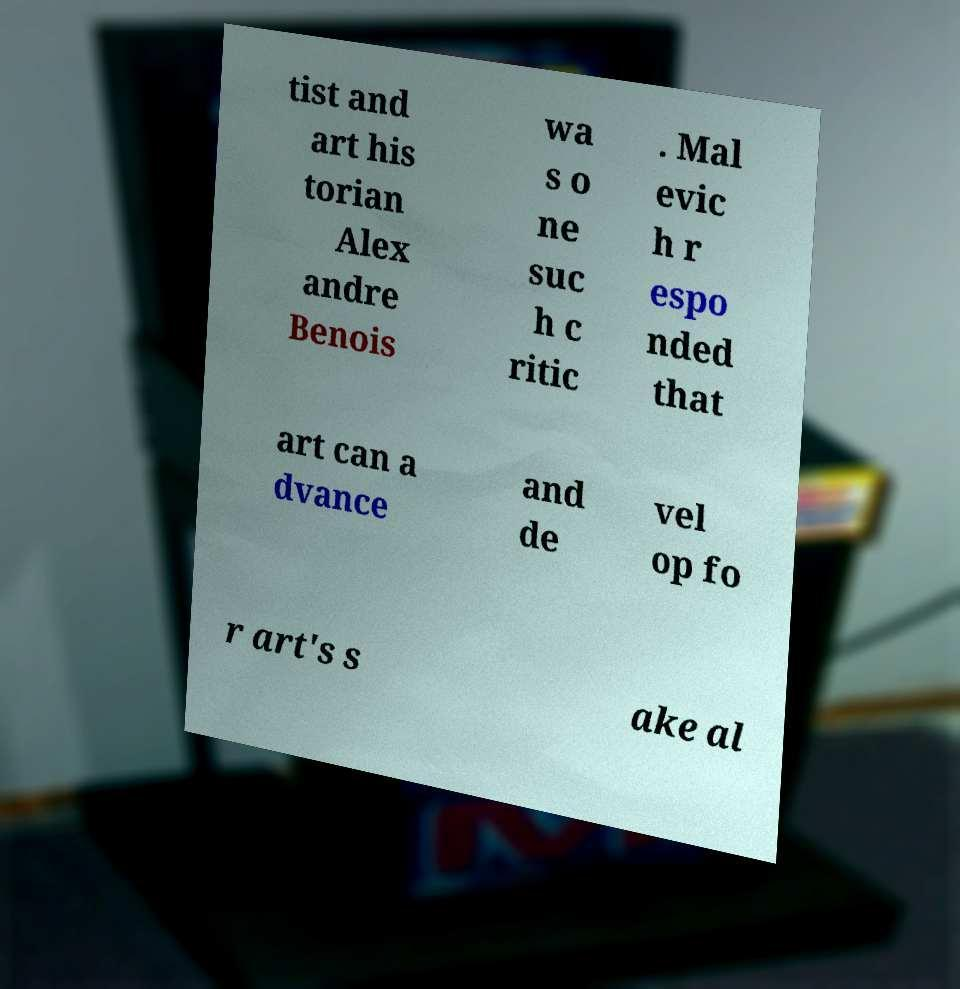There's text embedded in this image that I need extracted. Can you transcribe it verbatim? tist and art his torian Alex andre Benois wa s o ne suc h c ritic . Mal evic h r espo nded that art can a dvance and de vel op fo r art's s ake al 